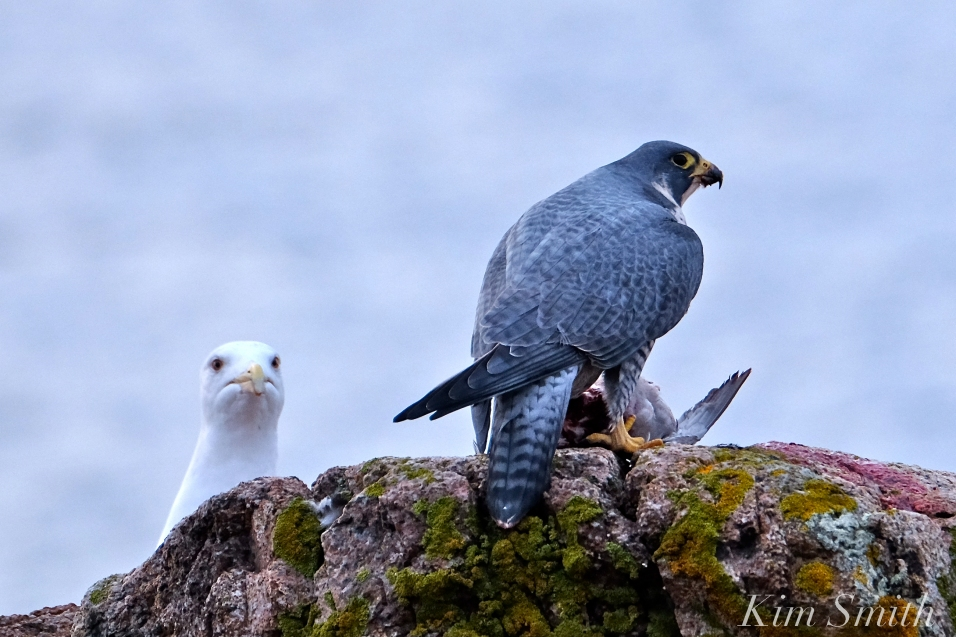What wild and imaginative backstory could be behind this moment capturing the Peregrine Falcon and the gull? In a world not so different from ours, where birds have their own realms and rivalries, the Peregrine Falcon, known as Talon the Swift, is a fierce guardian of the coastal skies. The gull, Whitecrest, belongs to an ancient avian society that scavenges the shoreline and has a pact of non-aggression with the falcons. However, tales speak of a powerful gem hidden in the heart of the gull's territory, a gem that grants its possessor unrivaled vision over the seas. Talon has just returned from a daring quest, clutching the gem concealed within the prey. This scene captures the moment of tension as Whitecrest discovers Talon's secret mission. The dynamic here is not just about prey but a larger, mystical struggle for power and control over the coastal skies. This single photo is a snapshot in time of an ongoing saga filled with intrigue, betrayal, and the quest for power in a hidden kingdom of the birds. 